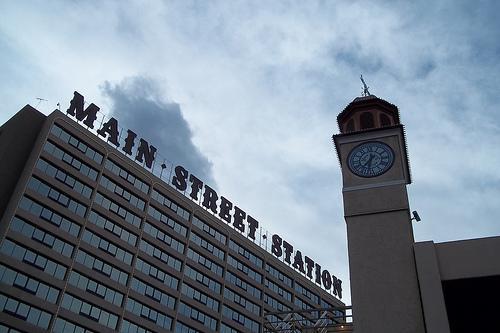How many words are on the building?
Give a very brief answer. 3. How many clocks can be seen?
Give a very brief answer. 1. How many numbers are on the clock tower?
Give a very brief answer. 12. 